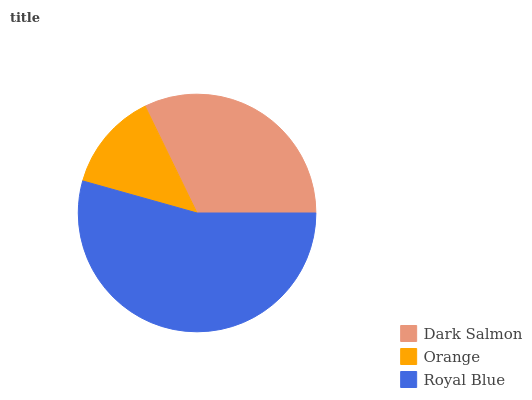Is Orange the minimum?
Answer yes or no. Yes. Is Royal Blue the maximum?
Answer yes or no. Yes. Is Royal Blue the minimum?
Answer yes or no. No. Is Orange the maximum?
Answer yes or no. No. Is Royal Blue greater than Orange?
Answer yes or no. Yes. Is Orange less than Royal Blue?
Answer yes or no. Yes. Is Orange greater than Royal Blue?
Answer yes or no. No. Is Royal Blue less than Orange?
Answer yes or no. No. Is Dark Salmon the high median?
Answer yes or no. Yes. Is Dark Salmon the low median?
Answer yes or no. Yes. Is Royal Blue the high median?
Answer yes or no. No. Is Orange the low median?
Answer yes or no. No. 